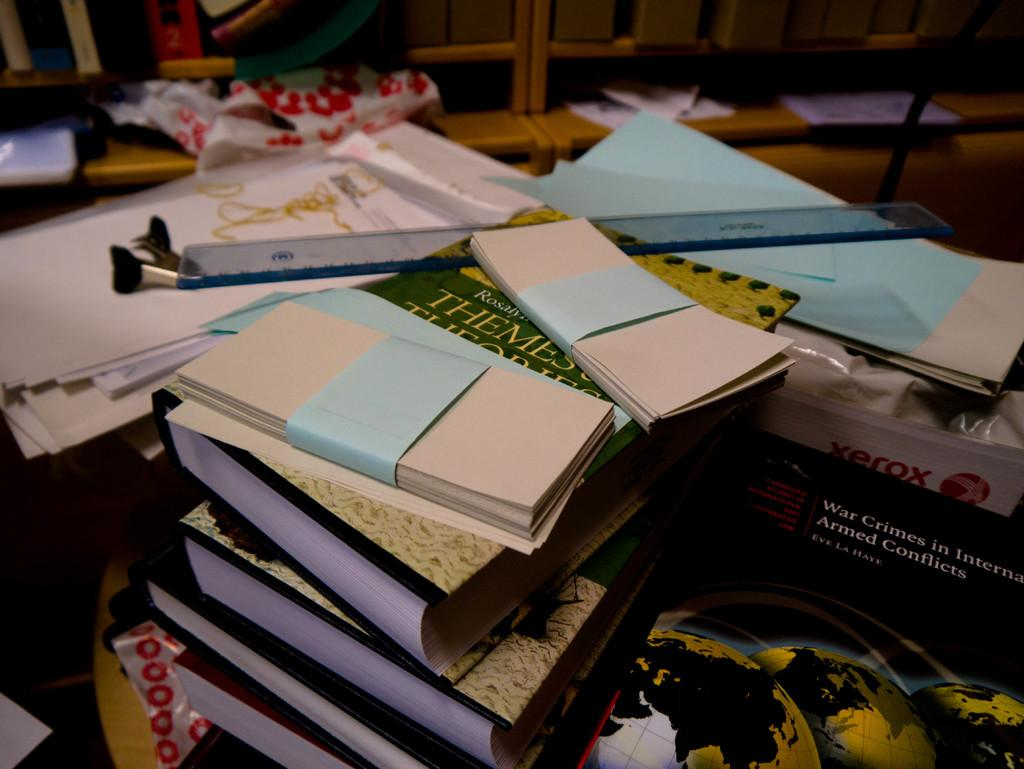<image>
Describe the image concisely. Books on top of one another with one that says XEROX in red. 